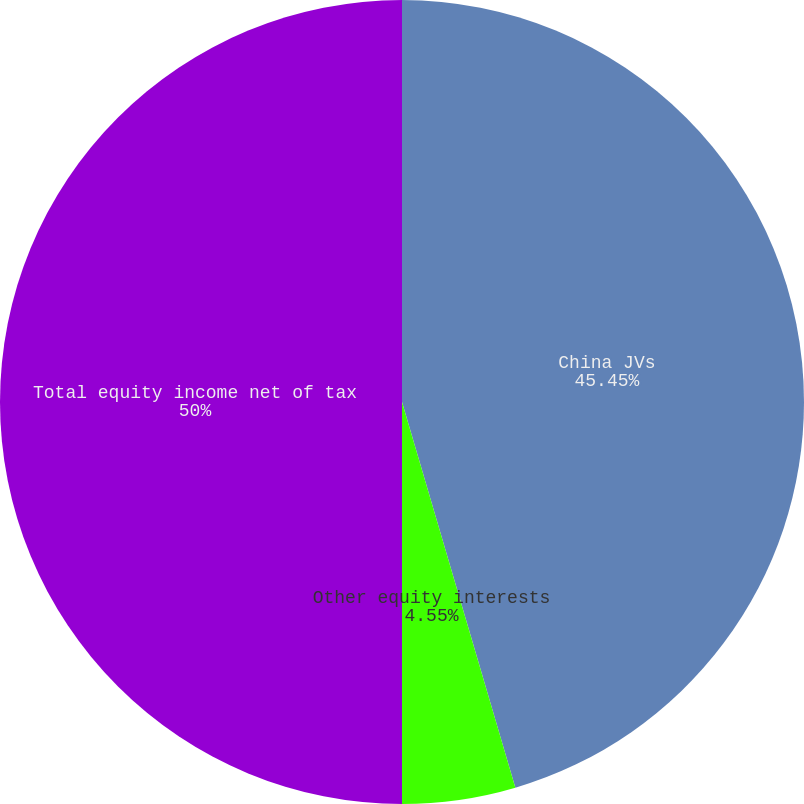<chart> <loc_0><loc_0><loc_500><loc_500><pie_chart><fcel>China JVs<fcel>Other equity interests<fcel>Total equity income net of tax<nl><fcel>45.45%<fcel>4.55%<fcel>50.0%<nl></chart> 